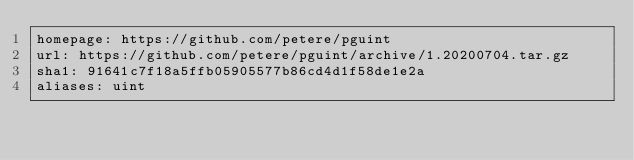<code> <loc_0><loc_0><loc_500><loc_500><_YAML_>homepage: https://github.com/petere/pguint
url: https://github.com/petere/pguint/archive/1.20200704.tar.gz
sha1: 91641c7f18a5ffb05905577b86cd4d1f58de1e2a
aliases: uint
</code> 